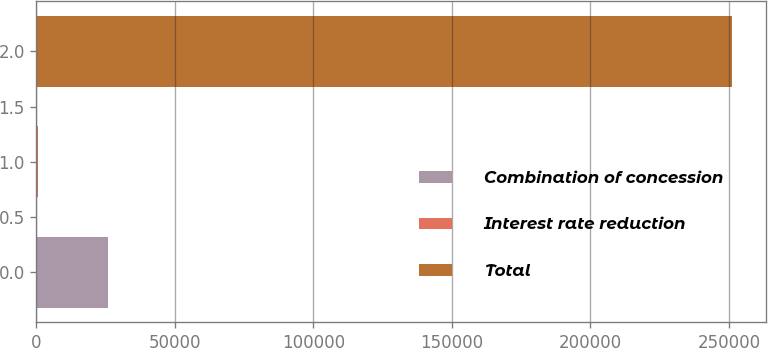Convert chart to OTSL. <chart><loc_0><loc_0><loc_500><loc_500><bar_chart><fcel>Combination of concession<fcel>Interest rate reduction<fcel>Total<nl><fcel>25739<fcel>708<fcel>251018<nl></chart> 